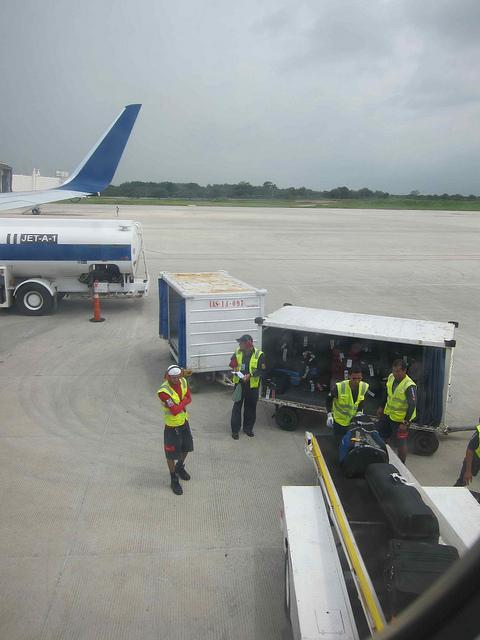What are they doing with the luggage? loading 